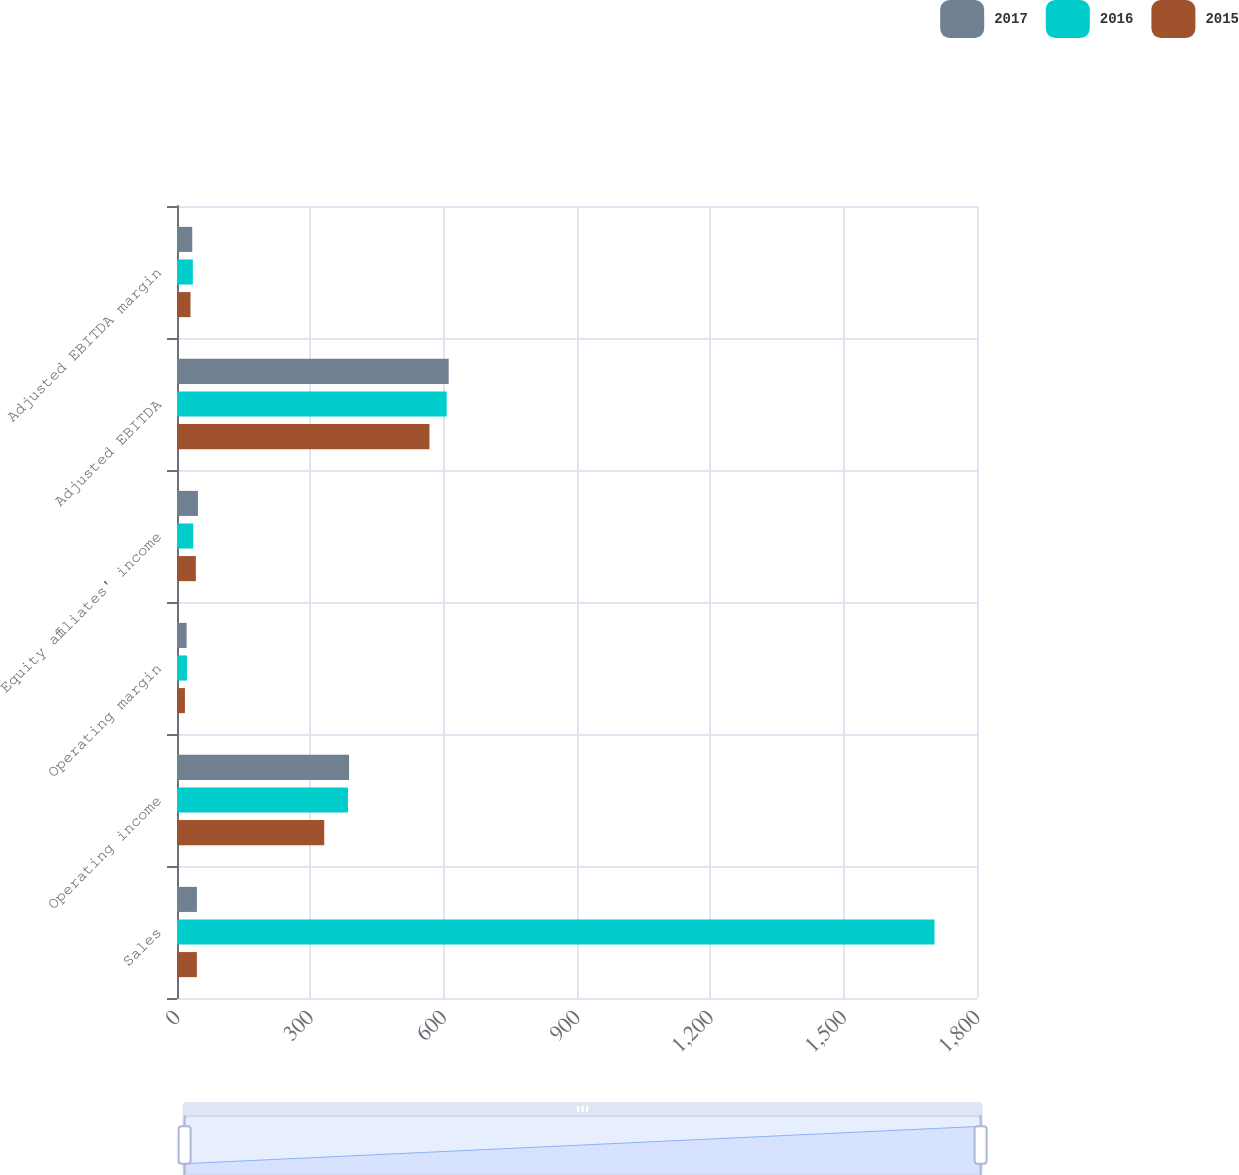<chart> <loc_0><loc_0><loc_500><loc_500><stacked_bar_chart><ecel><fcel>Sales<fcel>Operating income<fcel>Operating margin<fcel>Equity affiliates' income<fcel>Adjusted EBITDA<fcel>Adjusted EBITDA margin<nl><fcel>2017<fcel>44.75<fcel>387.1<fcel>21.7<fcel>47.1<fcel>611.3<fcel>34.3<nl><fcel>2016<fcel>1704.4<fcel>384.6<fcel>22.6<fcel>36.5<fcel>606.8<fcel>35.6<nl><fcel>2015<fcel>44.75<fcel>331.3<fcel>17.8<fcel>42.4<fcel>568<fcel>30.4<nl></chart> 